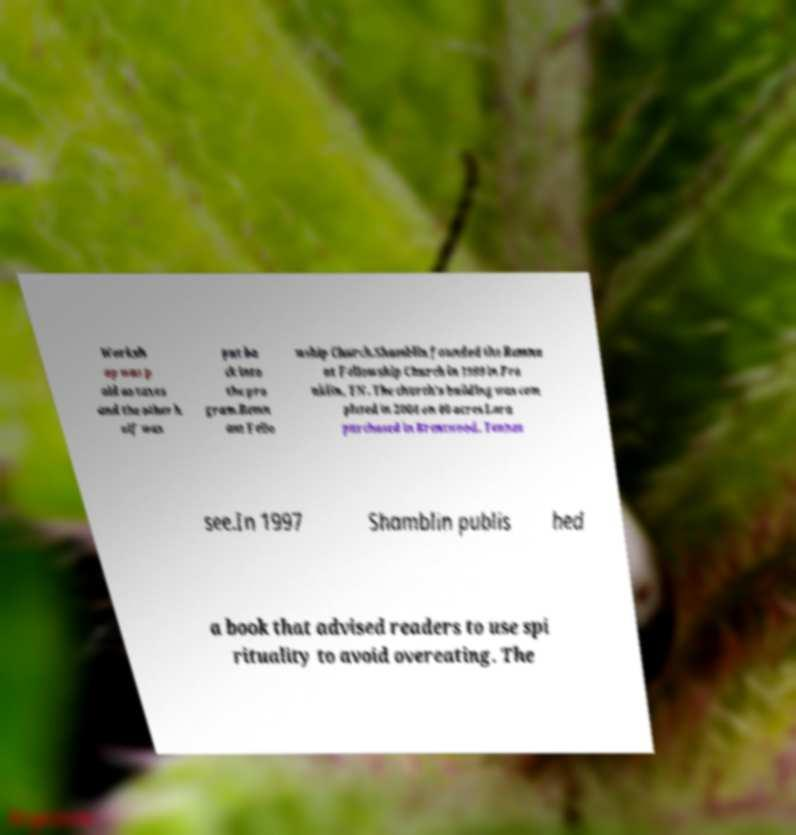There's text embedded in this image that I need extracted. Can you transcribe it verbatim? Worksh op was p aid as taxes and the other h alf was put ba ck into the pro gram.Remn ant Fello wship Church.Shamblin founded the Remna nt Fellowship Church in 1999 in Fra nklin, TN. The church's building was com pleted in 2004 on 40 acres Lara purchased in Brentwood, Tennes see.In 1997 Shamblin publis hed a book that advised readers to use spi rituality to avoid overeating. The 